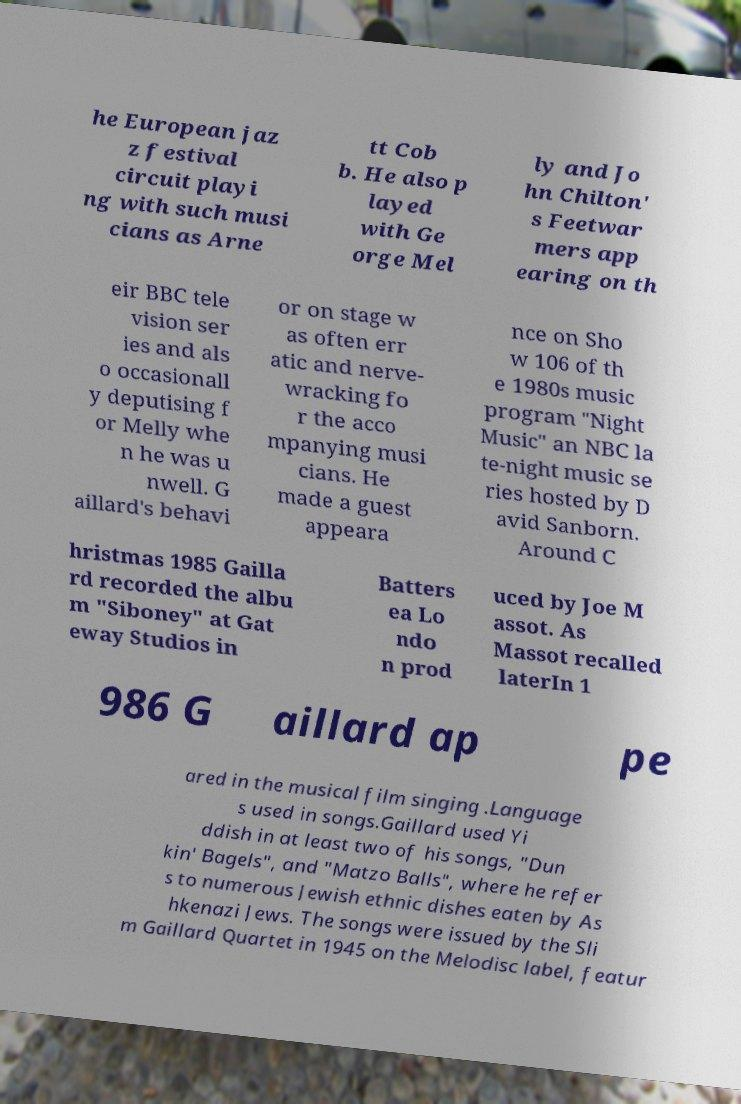There's text embedded in this image that I need extracted. Can you transcribe it verbatim? he European jaz z festival circuit playi ng with such musi cians as Arne tt Cob b. He also p layed with Ge orge Mel ly and Jo hn Chilton' s Feetwar mers app earing on th eir BBC tele vision ser ies and als o occasionall y deputising f or Melly whe n he was u nwell. G aillard's behavi or on stage w as often err atic and nerve- wracking fo r the acco mpanying musi cians. He made a guest appeara nce on Sho w 106 of th e 1980s music program "Night Music" an NBC la te-night music se ries hosted by D avid Sanborn. Around C hristmas 1985 Gailla rd recorded the albu m "Siboney" at Gat eway Studios in Batters ea Lo ndo n prod uced by Joe M assot. As Massot recalled laterIn 1 986 G aillard ap pe ared in the musical film singing .Language s used in songs.Gaillard used Yi ddish in at least two of his songs, "Dun kin' Bagels", and "Matzo Balls", where he refer s to numerous Jewish ethnic dishes eaten by As hkenazi Jews. The songs were issued by the Sli m Gaillard Quartet in 1945 on the Melodisc label, featur 